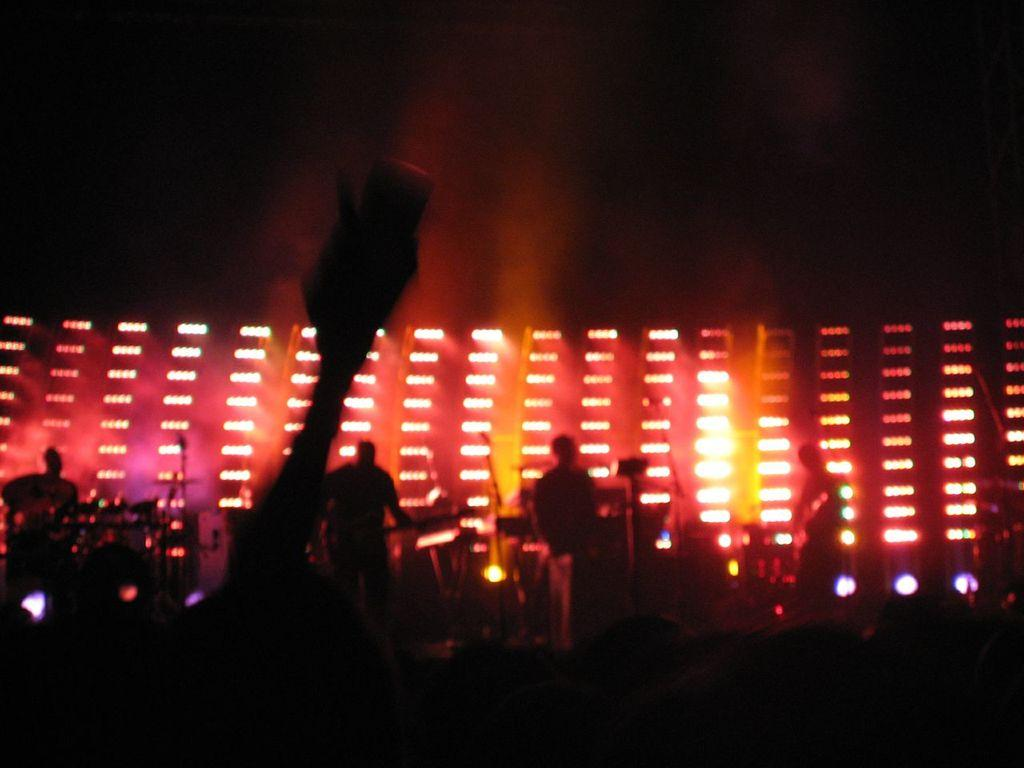What is happening on the stage in the image? There are people standing on the stage. What can be seen illuminating the stage? Stage lights are present in the image. Are there any other objects on the stage besides the people? Yes, there are other objects on the stage. What type of cracker is being used as a prop by the performers on the stage? There is no cracker present in the image, and no indication that any props are being used by the performers. 